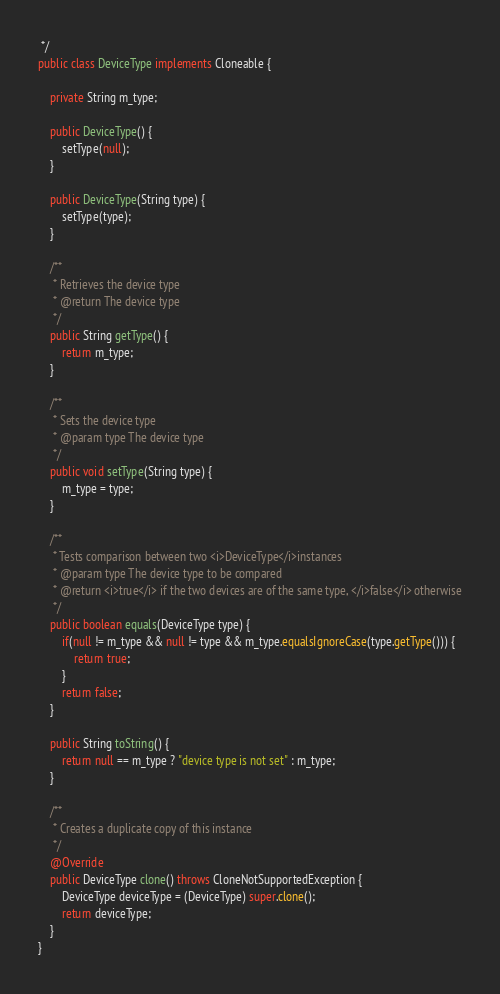<code> <loc_0><loc_0><loc_500><loc_500><_Java_> */
public class DeviceType implements Cloneable {

    private String m_type;

    public DeviceType() {
        setType(null);
    }

    public DeviceType(String type) {
        setType(type);
    }

    /**
     * Retrieves the device type
     * @return The device type
     */
    public String getType() {
        return m_type;
    }

    /**
     * Sets the device type
     * @param type The device type
     */
    public void setType(String type) {
        m_type = type;
    }

    /**
     * Tests comparison between two <i>DeviceType</i>instances 
     * @param type The device type to be compared
     * @return <i>true</i> if the two devices are of the same type, </i>false</i> otherwise
     */
    public boolean equals(DeviceType type) {
        if(null != m_type && null != type && m_type.equalsIgnoreCase(type.getType())) {
            return true;
        }
        return false;
    }

    public String toString() {
        return null == m_type ? "device type is not set" : m_type;
    }

    /**
     * Creates a duplicate copy of this instance
     */
    @Override
    public DeviceType clone() throws CloneNotSupportedException {
        DeviceType deviceType = (DeviceType) super.clone();
        return deviceType;
    }
}
</code> 